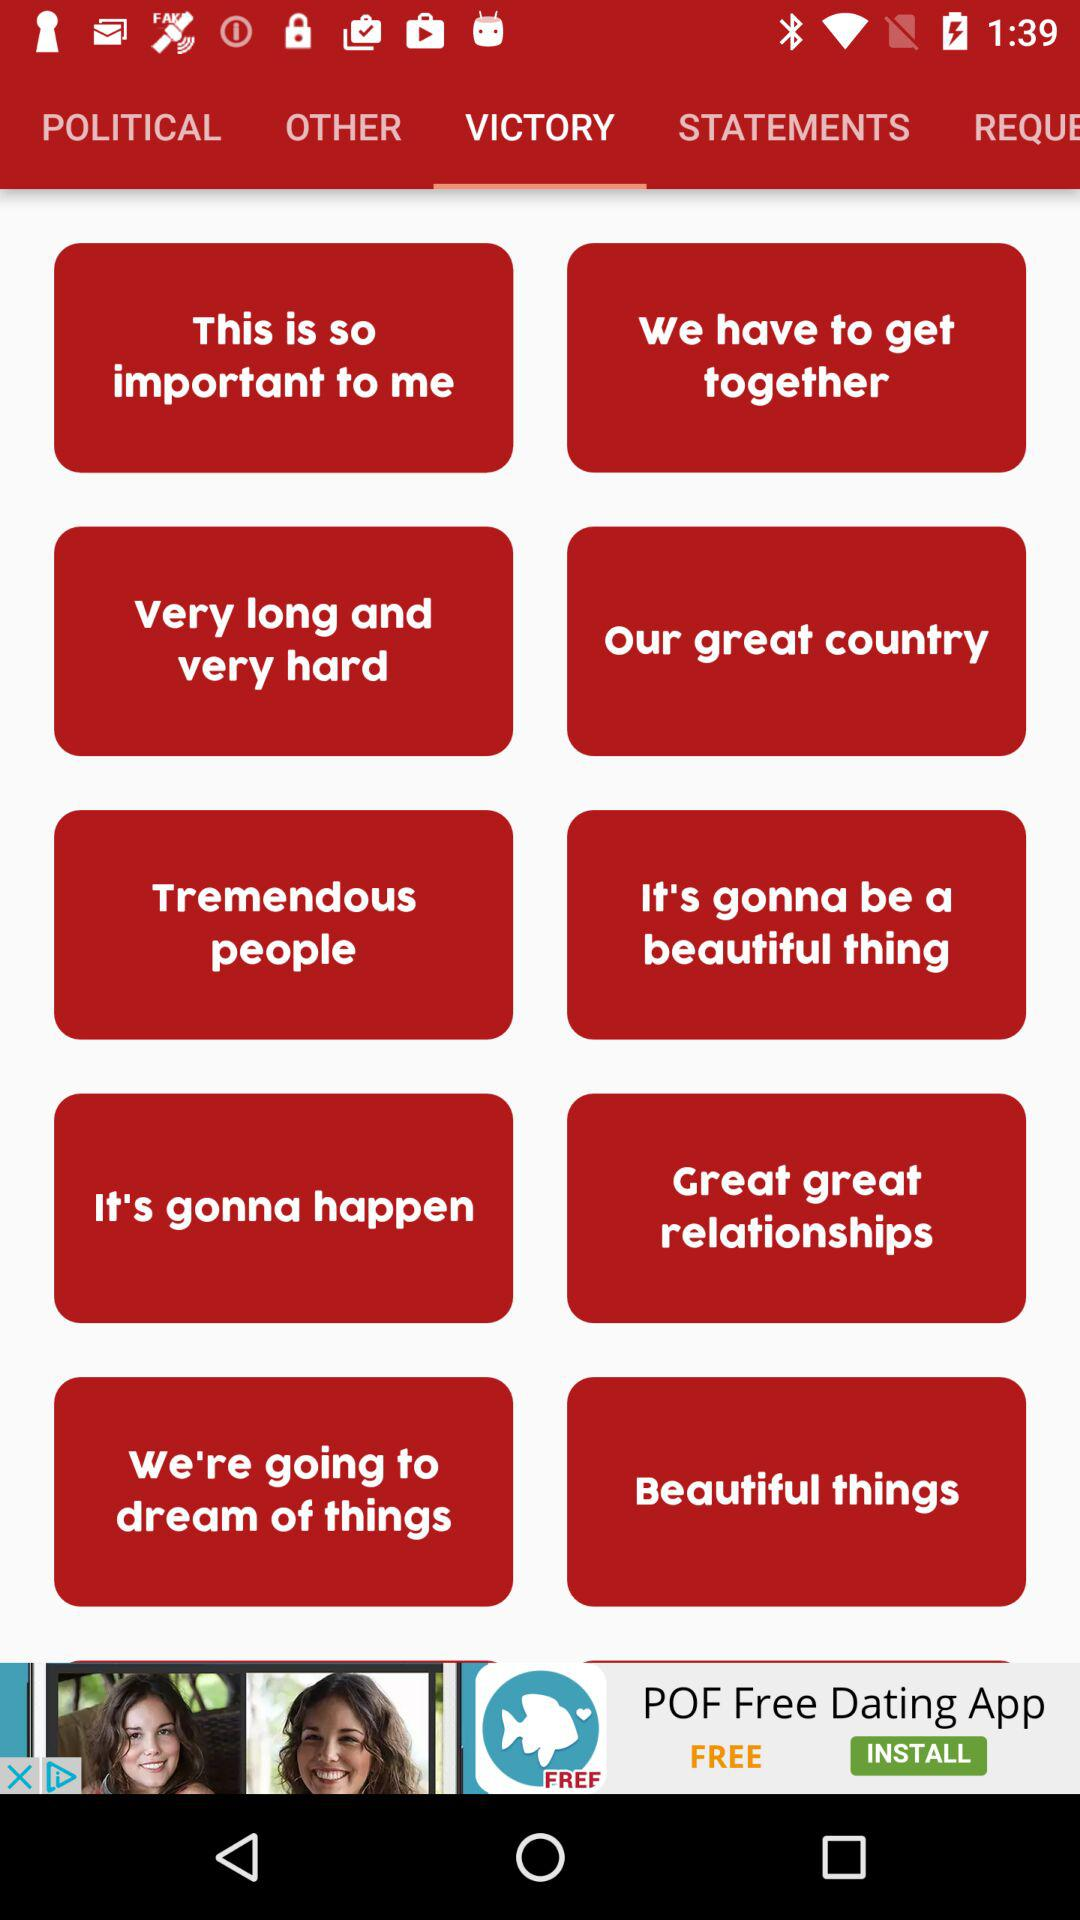What is the selected tab? The selected tab is "VICTORY". 